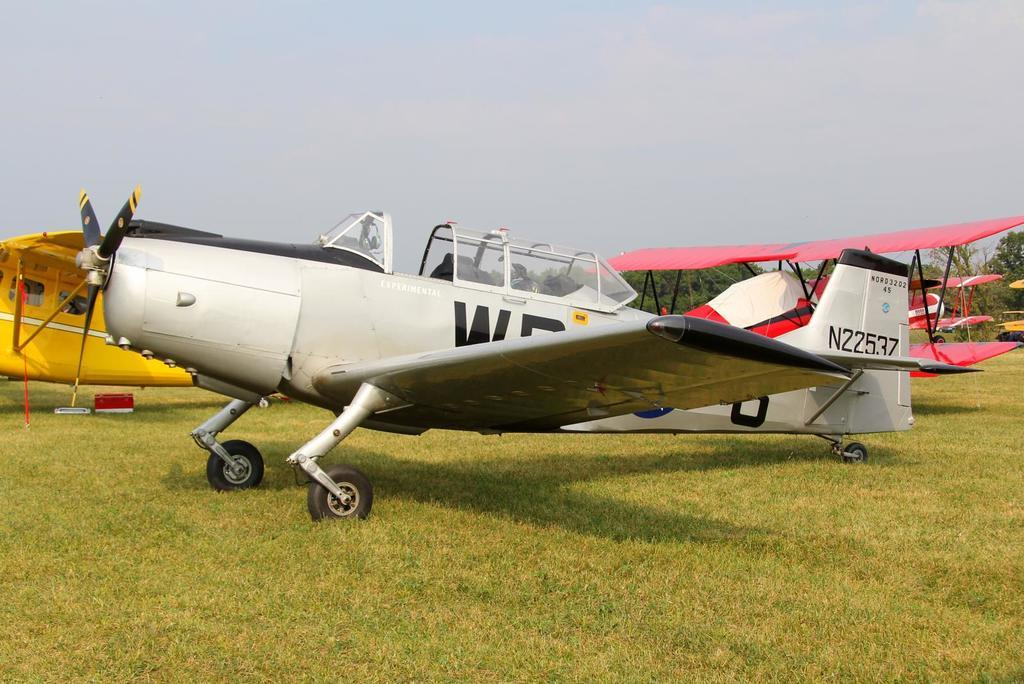<image>
Provide a brief description of the given image. A small single prop plane has the identifier N22357 on the tail. 